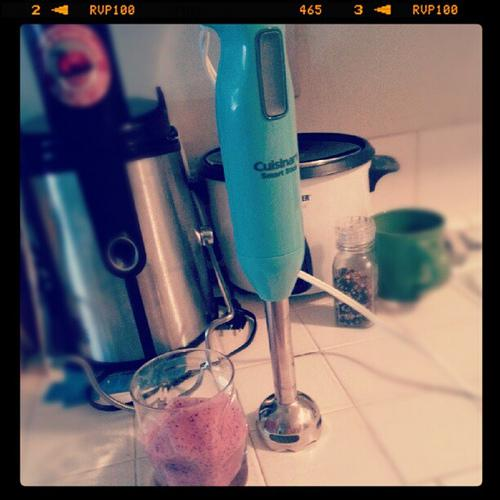Question: who uses this object?
Choices:
A. Firemen.
B. Police Officers.
C. Soldiers.
D. People.
Answer with the letter. Answer: D Question: what did the hand mixer make?
Choices:
A. Smoothie.
B. Salsa.
C. Dip.
D. Soup.
Answer with the letter. Answer: A Question: what company makes the mixer?
Choices:
A. Cuisinart.
B. Vitamix.
C. Hamilton Beach.
D. Magic Bullet.
Answer with the letter. Answer: A Question: what color is the hand mixer?
Choices:
A. Red.
B. Blue.
C. White.
D. Yellow.
Answer with the letter. Answer: B Question: where is the green coffee cup?
Choices:
A. Right.
B. Left.
C. Middle.
D. Front.
Answer with the letter. Answer: A Question: what color is the tile?
Choices:
A. Black.
B. White.
C. Red.
D. Blue.
Answer with the letter. Answer: B 